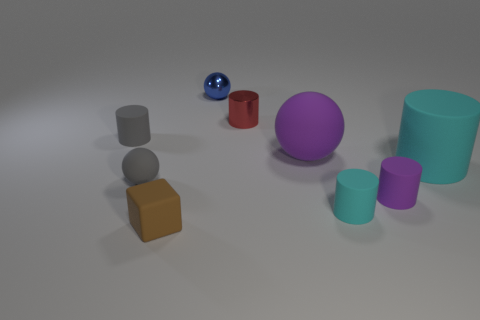What is the shape of the rubber thing that is the same color as the big rubber cylinder?
Give a very brief answer. Cylinder. How many other things are there of the same material as the tiny gray ball?
Offer a terse response. 6. There is a brown rubber block; are there any matte blocks to the left of it?
Provide a short and direct response. No. Is the size of the brown object the same as the sphere on the right side of the tiny metallic cylinder?
Make the answer very short. No. There is a tiny cylinder behind the tiny matte cylinder to the left of the tiny red metal cylinder; what color is it?
Ensure brevity in your answer.  Red. Is the size of the blue sphere the same as the red cylinder?
Provide a short and direct response. Yes. The sphere that is both to the left of the big purple rubber thing and behind the big cyan object is what color?
Offer a terse response. Blue. What is the size of the gray cylinder?
Your answer should be compact. Small. There is a rubber cylinder that is in front of the small purple matte thing; is its color the same as the large cylinder?
Your answer should be very brief. Yes. Is the number of shiny spheres that are on the right side of the red metal object greater than the number of big balls on the left side of the tiny brown block?
Provide a succinct answer. No. 